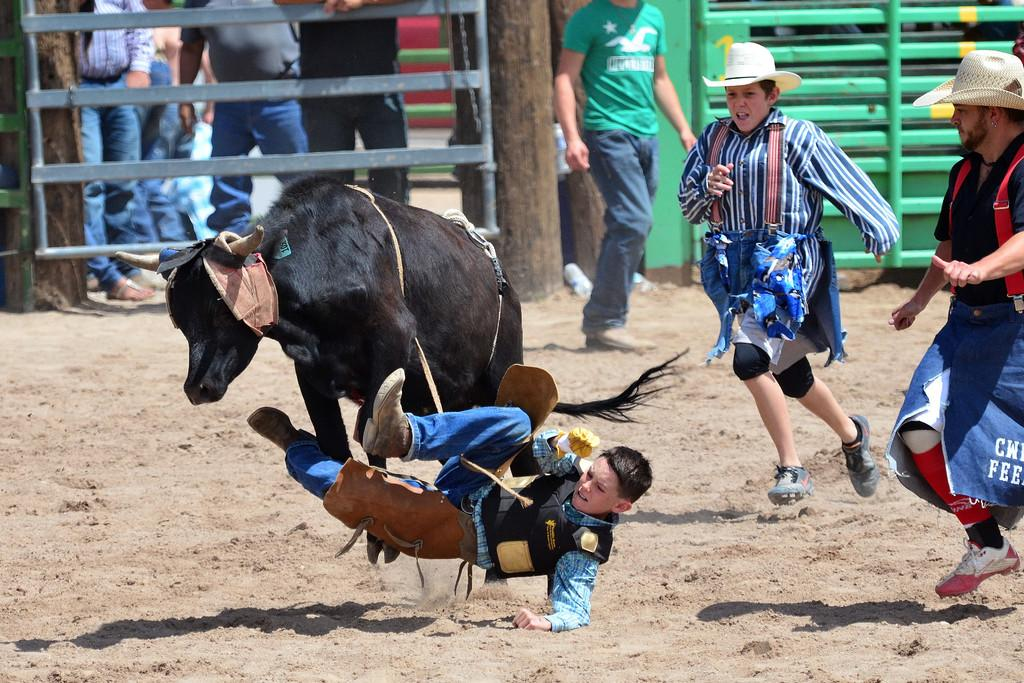What type of animal can be seen in the image? There is an animal in the image, but we cannot determine its exact species from the provided facts. How many people are on the ground in the image? There are four people on the ground in the image. What can be seen in the background of the image? In the background of the image, there are fences, wooden poles, and some people. Are there any objects visible in the background of the image? Yes, there are some objects in the background of the image. What type of smoke can be seen coming from the animal's mouth in the image? There is no smoke visible in the image, nor is there any indication that the animal is exhaling or producing smoke. 